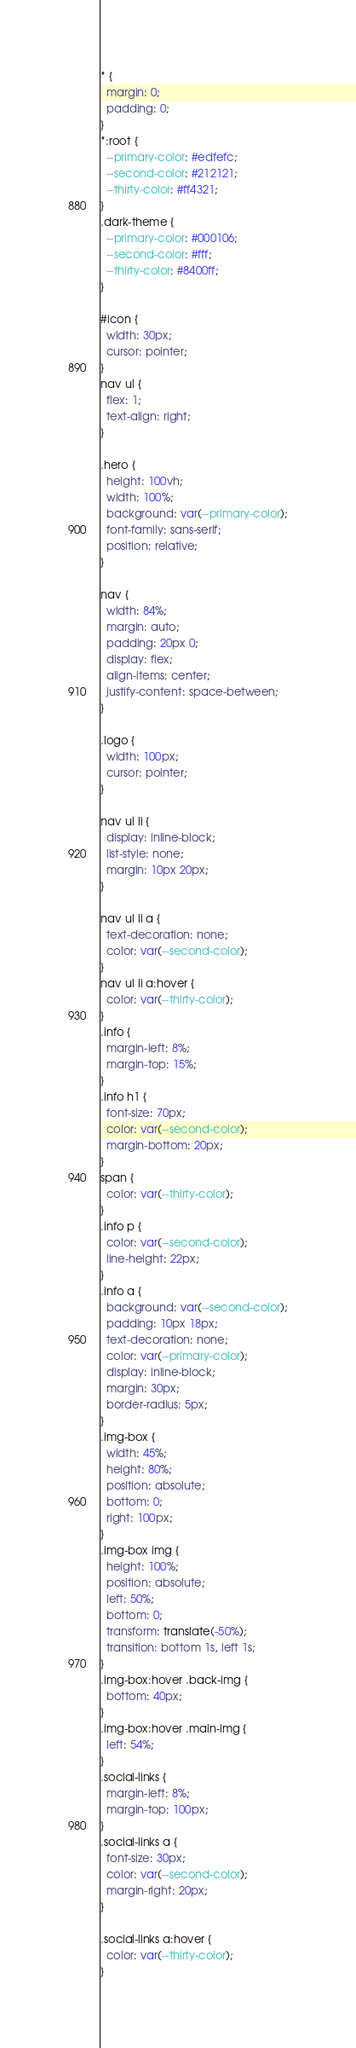<code> <loc_0><loc_0><loc_500><loc_500><_CSS_>* {
  margin: 0;
  padding: 0;
}
*:root {
  --primary-color: #edfefc;
  --second-color: #212121;
  --thirty-color: #ff4321;
}
.dark-theme {
  --primary-color: #000106;
  --second-color: #fff;
  --thirty-color: #8400ff;
}

#icon {
  width: 30px;
  cursor: pointer;
}
nav ul {
  flex: 1;
  text-align: right;
}

.hero {
  height: 100vh;
  width: 100%;
  background: var(--primary-color);
  font-family: sans-serif;
  position: relative;
}

nav {
  width: 84%;
  margin: auto;
  padding: 20px 0;
  display: flex;
  align-items: center;
  justify-content: space-between;
}

.logo {
  width: 100px;
  cursor: pointer;
}

nav ul li {
  display: inline-block;
  list-style: none;
  margin: 10px 20px;
}

nav ul li a {
  text-decoration: none;
  color: var(--second-color);
}
nav ul li a:hover {
  color: var(--thirty-color);
}
.info {
  margin-left: 8%;
  margin-top: 15%;
}
.info h1 {
  font-size: 70px;
  color: var(--second-color);
  margin-bottom: 20px;
}
span {
  color: var(--thirty-color);
}
.info p {
  color: var(--second-color);
  line-height: 22px;
}
.info a {
  background: var(--second-color);
  padding: 10px 18px;
  text-decoration: none;
  color: var(--primary-color);
  display: inline-block;
  margin: 30px;
  border-radius: 5px;
}
.img-box {
  width: 45%;
  height: 80%;
  position: absolute;
  bottom: 0;
  right: 100px;
}
.img-box img {
  height: 100%;
  position: absolute;
  left: 50%;
  bottom: 0;
  transform: translate(-50%);
  transition: bottom 1s, left 1s;
}
.img-box:hover .back-img {
  bottom: 40px;
}
.img-box:hover .main-img {
  left: 54%;
}
.social-links {
  margin-left: 8%;
  margin-top: 100px;
}
.social-links a {
  font-size: 30px;
  color: var(--second-color);
  margin-right: 20px;
}

.social-links a:hover {
  color: var(--thirty-color);
}
</code> 